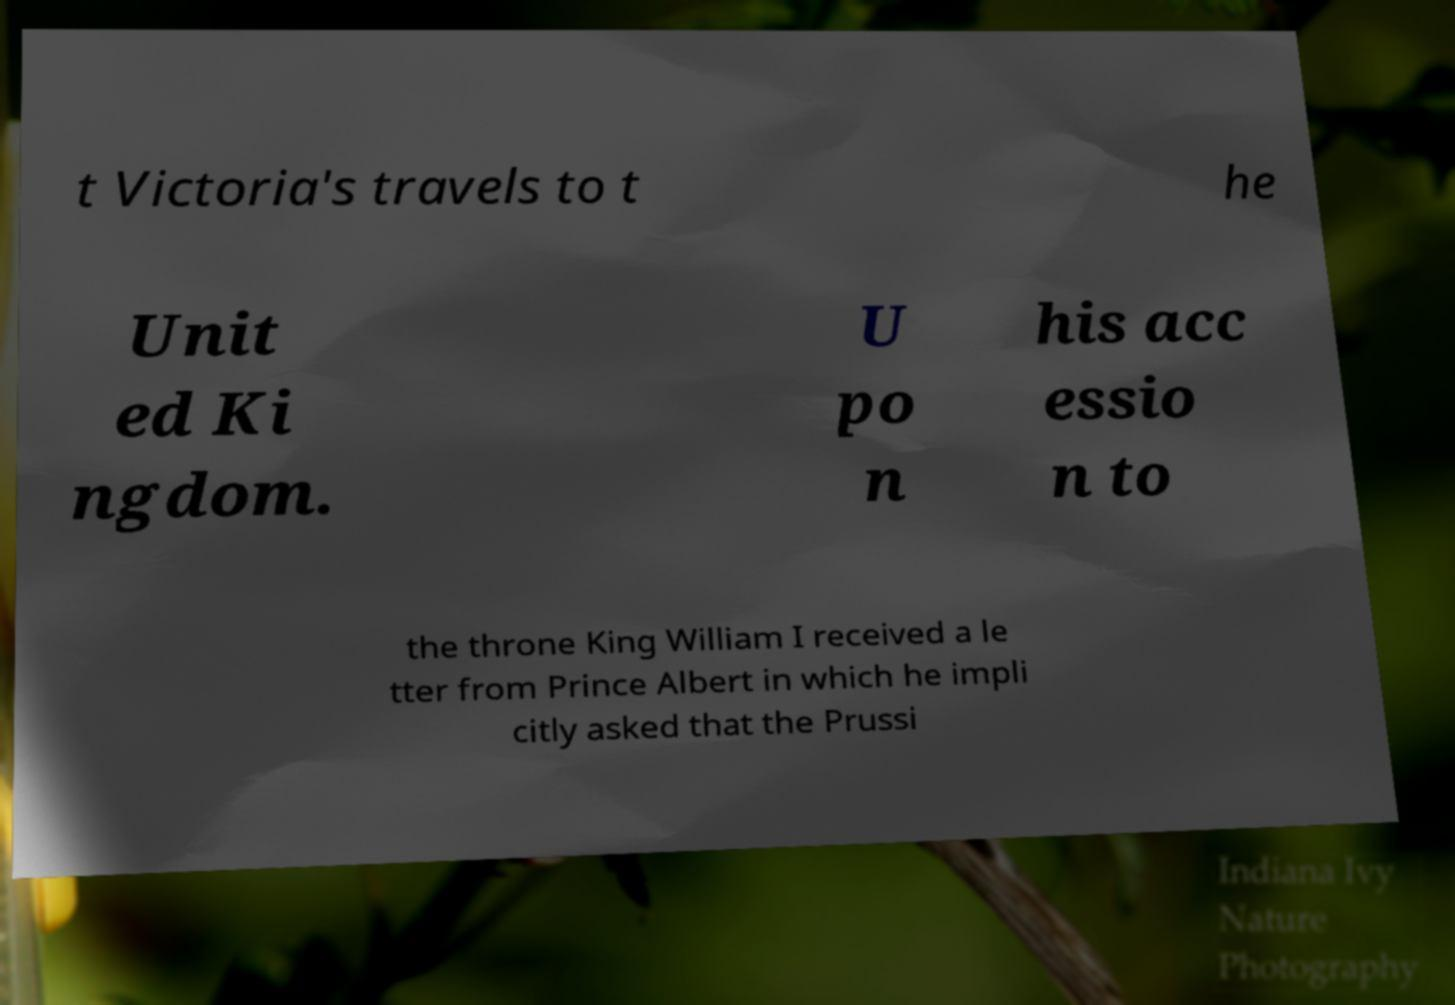Please identify and transcribe the text found in this image. t Victoria's travels to t he Unit ed Ki ngdom. U po n his acc essio n to the throne King William I received a le tter from Prince Albert in which he impli citly asked that the Prussi 